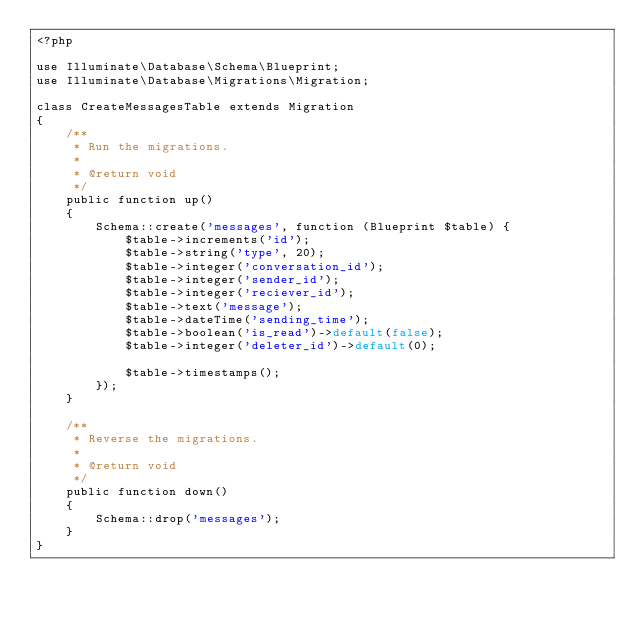<code> <loc_0><loc_0><loc_500><loc_500><_PHP_><?php

use Illuminate\Database\Schema\Blueprint;
use Illuminate\Database\Migrations\Migration;

class CreateMessagesTable extends Migration
{
    /**
     * Run the migrations.
     *
     * @return void
     */
    public function up()
    {
        Schema::create('messages', function (Blueprint $table) {
            $table->increments('id');
            $table->string('type', 20);
            $table->integer('conversation_id');
            $table->integer('sender_id');
            $table->integer('reciever_id');
            $table->text('message');
            $table->dateTime('sending_time');
            $table->boolean('is_read')->default(false);
            $table->integer('deleter_id')->default(0);

            $table->timestamps();
        });
    }

    /**
     * Reverse the migrations.
     *
     * @return void
     */
    public function down()
    {
        Schema::drop('messages');
    }
}
</code> 